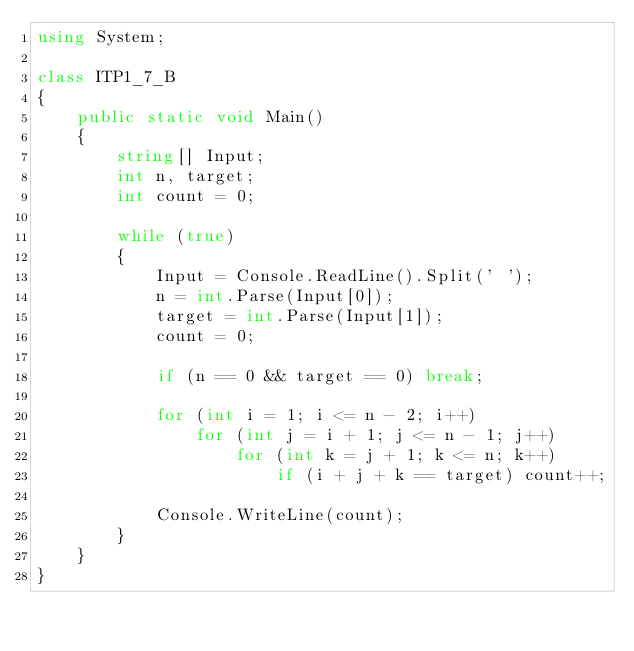<code> <loc_0><loc_0><loc_500><loc_500><_C#_>using System;

class ITP1_7_B
{
    public static void Main()
    {
        string[] Input;
        int n, target;
        int count = 0;

        while (true)
        {
            Input = Console.ReadLine().Split(' ');
            n = int.Parse(Input[0]);
            target = int.Parse(Input[1]);
            count = 0;

            if (n == 0 && target == 0) break;

            for (int i = 1; i <= n - 2; i++)
                for (int j = i + 1; j <= n - 1; j++)
                    for (int k = j + 1; k <= n; k++)
                        if (i + j + k == target) count++;

            Console.WriteLine(count);
        }
    }
}</code> 